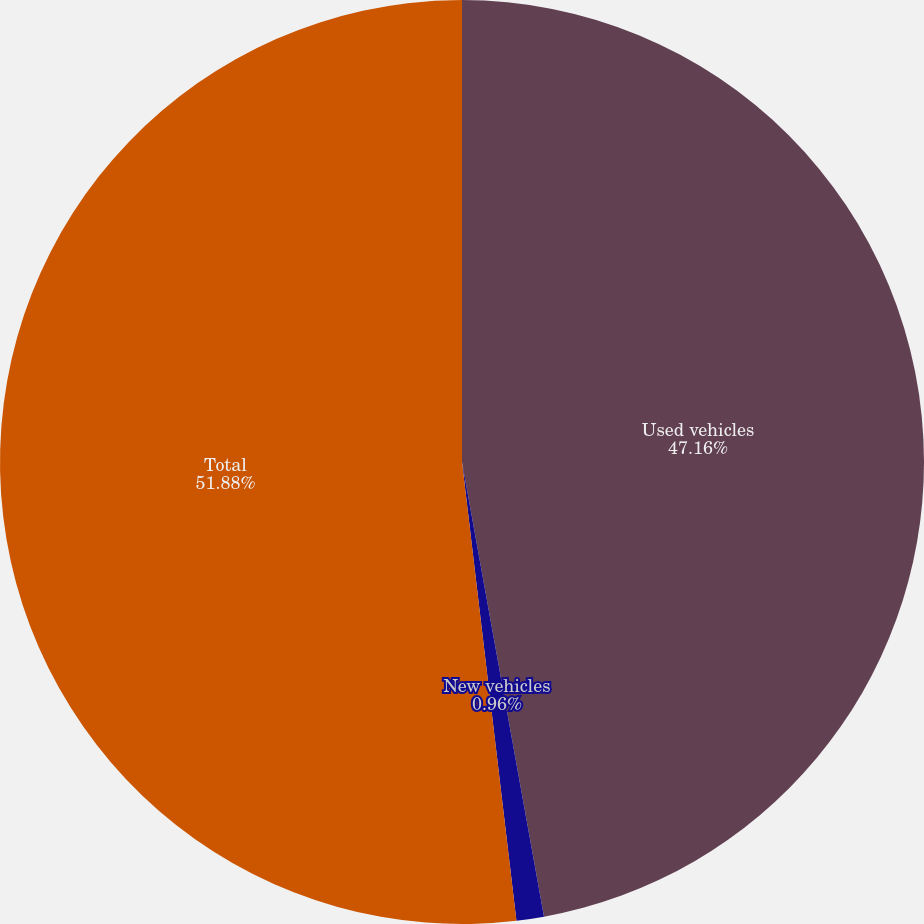Convert chart to OTSL. <chart><loc_0><loc_0><loc_500><loc_500><pie_chart><fcel>Used vehicles<fcel>New vehicles<fcel>Total<nl><fcel>47.16%<fcel>0.96%<fcel>51.88%<nl></chart> 